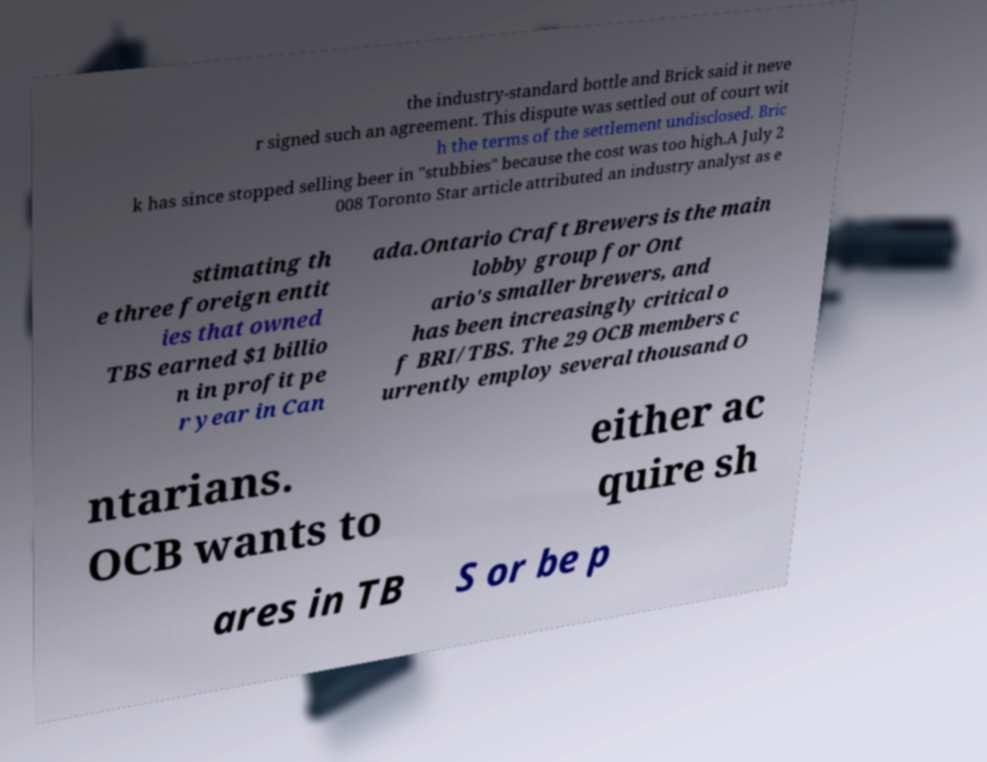Please read and relay the text visible in this image. What does it say? the industry-standard bottle and Brick said it neve r signed such an agreement. This dispute was settled out of court wit h the terms of the settlement undisclosed. Bric k has since stopped selling beer in "stubbies" because the cost was too high.A July 2 008 Toronto Star article attributed an industry analyst as e stimating th e three foreign entit ies that owned TBS earned $1 billio n in profit pe r year in Can ada.Ontario Craft Brewers is the main lobby group for Ont ario's smaller brewers, and has been increasingly critical o f BRI/TBS. The 29 OCB members c urrently employ several thousand O ntarians. OCB wants to either ac quire sh ares in TB S or be p 